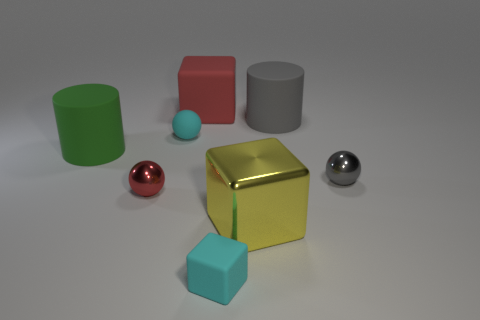There is another tiny metallic object that is the same shape as the gray metallic thing; what is its color?
Provide a short and direct response. Red. How many things are either small things that are in front of the green cylinder or small cyan objects that are in front of the small red shiny ball?
Provide a succinct answer. 3. What shape is the red metal object?
Give a very brief answer. Sphere. What is the shape of the small object that is the same color as the rubber ball?
Provide a short and direct response. Cube. What number of large cylinders are the same material as the yellow thing?
Keep it short and to the point. 0. The small cube is what color?
Offer a very short reply. Cyan. There is a shiny block that is the same size as the green thing; what is its color?
Offer a terse response. Yellow. Are there any small things that have the same color as the small rubber sphere?
Your response must be concise. Yes. There is a object in front of the large yellow metallic thing; does it have the same shape as the red object that is on the right side of the rubber sphere?
Provide a short and direct response. Yes. The ball that is the same color as the tiny rubber block is what size?
Ensure brevity in your answer.  Small. 